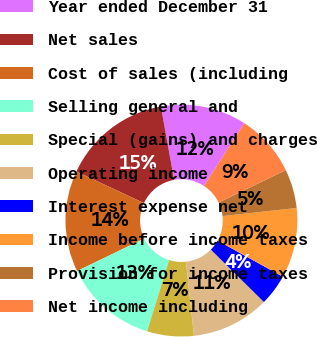Convert chart. <chart><loc_0><loc_0><loc_500><loc_500><pie_chart><fcel>Year ended December 31<fcel>Net sales<fcel>Cost of sales (including<fcel>Selling general and<fcel>Special (gains) and charges<fcel>Operating income<fcel>Interest expense net<fcel>Income before income taxes<fcel>Provision for income taxes<fcel>Net income including<nl><fcel>11.96%<fcel>15.22%<fcel>14.13%<fcel>13.04%<fcel>6.52%<fcel>10.87%<fcel>4.35%<fcel>9.78%<fcel>5.44%<fcel>8.7%<nl></chart> 